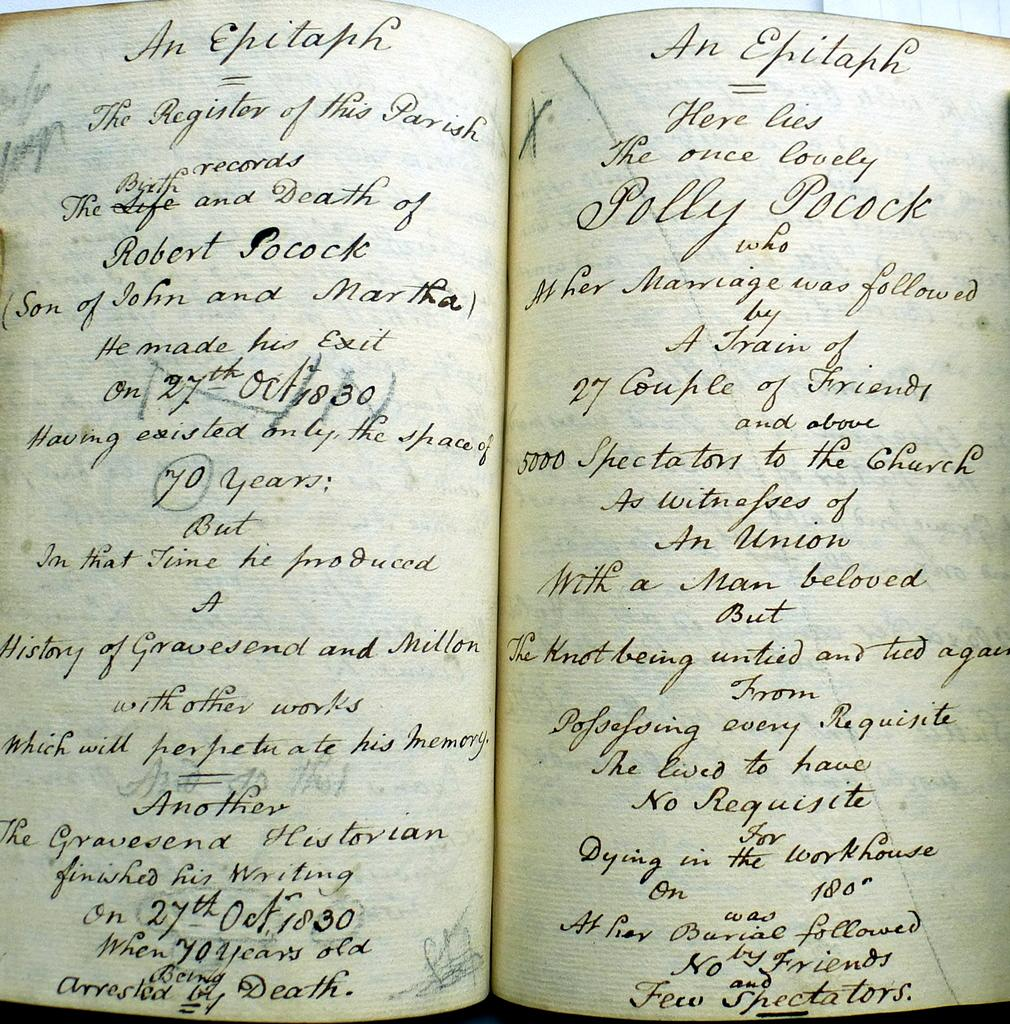Provide a one-sentence caption for the provided image. old hand written book sits open pages of an epitaph. 